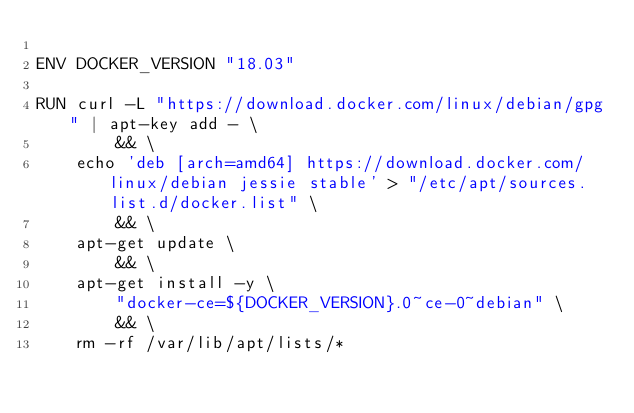<code> <loc_0><loc_0><loc_500><loc_500><_Dockerfile_>
ENV DOCKER_VERSION "18.03"

RUN curl -L "https://download.docker.com/linux/debian/gpg" | apt-key add - \
        && \
    echo 'deb [arch=amd64] https://download.docker.com/linux/debian jessie stable' > "/etc/apt/sources.list.d/docker.list" \
        && \
    apt-get update \
        && \
    apt-get install -y \
        "docker-ce=${DOCKER_VERSION}.0~ce-0~debian" \
        && \
    rm -rf /var/lib/apt/lists/*
</code> 